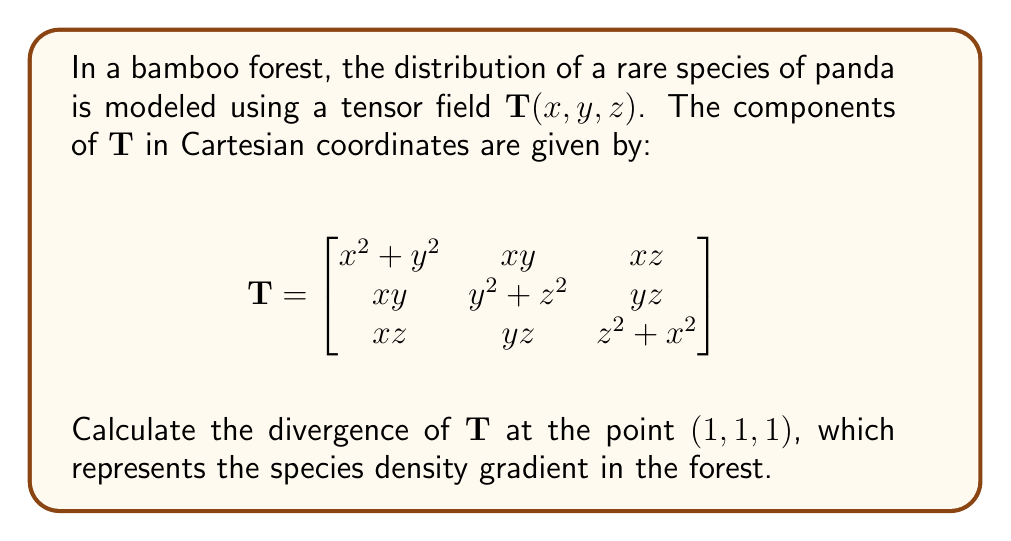Show me your answer to this math problem. To solve this problem, we need to follow these steps:

1) The divergence of a tensor field $\mathbf{T}$ in Cartesian coordinates is given by:

   $$\text{div}\mathbf{T} = \frac{\partial T_{xx}}{\partial x} + \frac{\partial T_{yy}}{\partial y} + \frac{\partial T_{zz}}{\partial z}$$

2) Let's calculate each partial derivative:

   $\frac{\partial T_{xx}}{\partial x} = \frac{\partial}{\partial x}(x^2 + y^2) = 2x$

   $\frac{\partial T_{yy}}{\partial y} = \frac{\partial}{\partial y}(y^2 + z^2) = 2y$

   $\frac{\partial T_{zz}}{\partial z} = \frac{\partial}{\partial z}(z^2 + x^2) = 2z$

3) Now, we sum these partial derivatives:

   $$\text{div}\mathbf{T} = 2x + 2y + 2z$$

4) Evaluate this at the point $(1,1,1)$:

   $$\text{div}\mathbf{T}(1,1,1) = 2(1) + 2(1) + 2(1) = 6$$

Thus, the divergence of $\mathbf{T}$ at $(1,1,1)$ is 6, indicating the rate at which the panda species density is changing at this point in the bamboo forest.
Answer: 6 